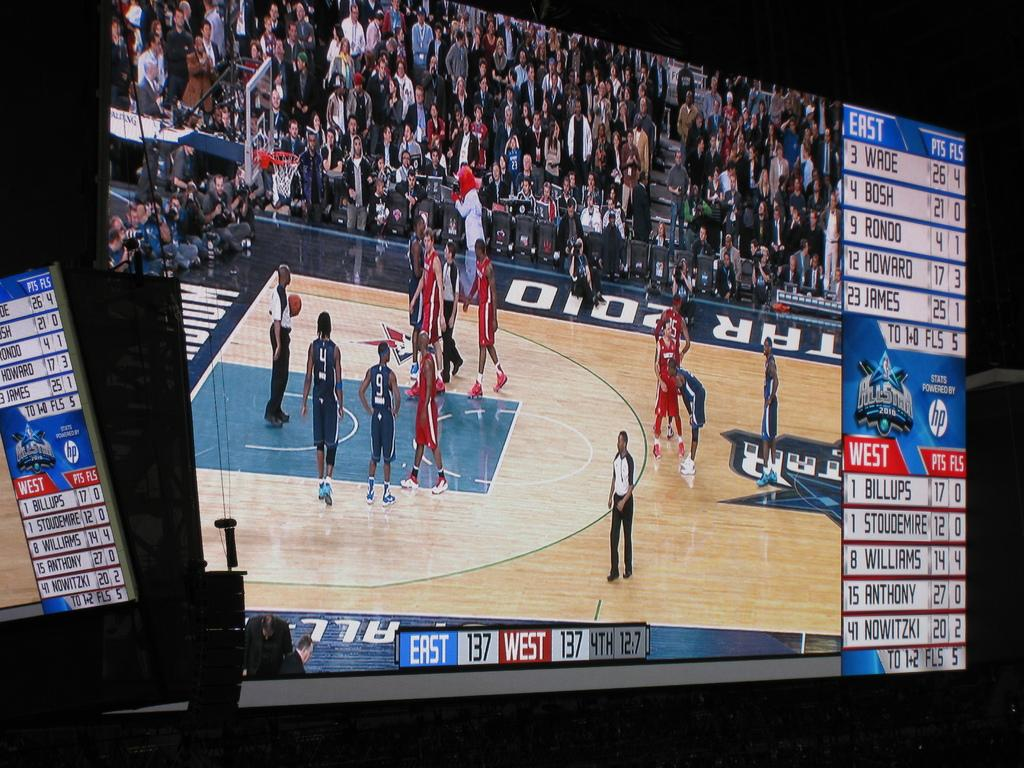Provide a one-sentence caption for the provided image. A basketball game is being shown on a tv screen with East 137 and West 137. 